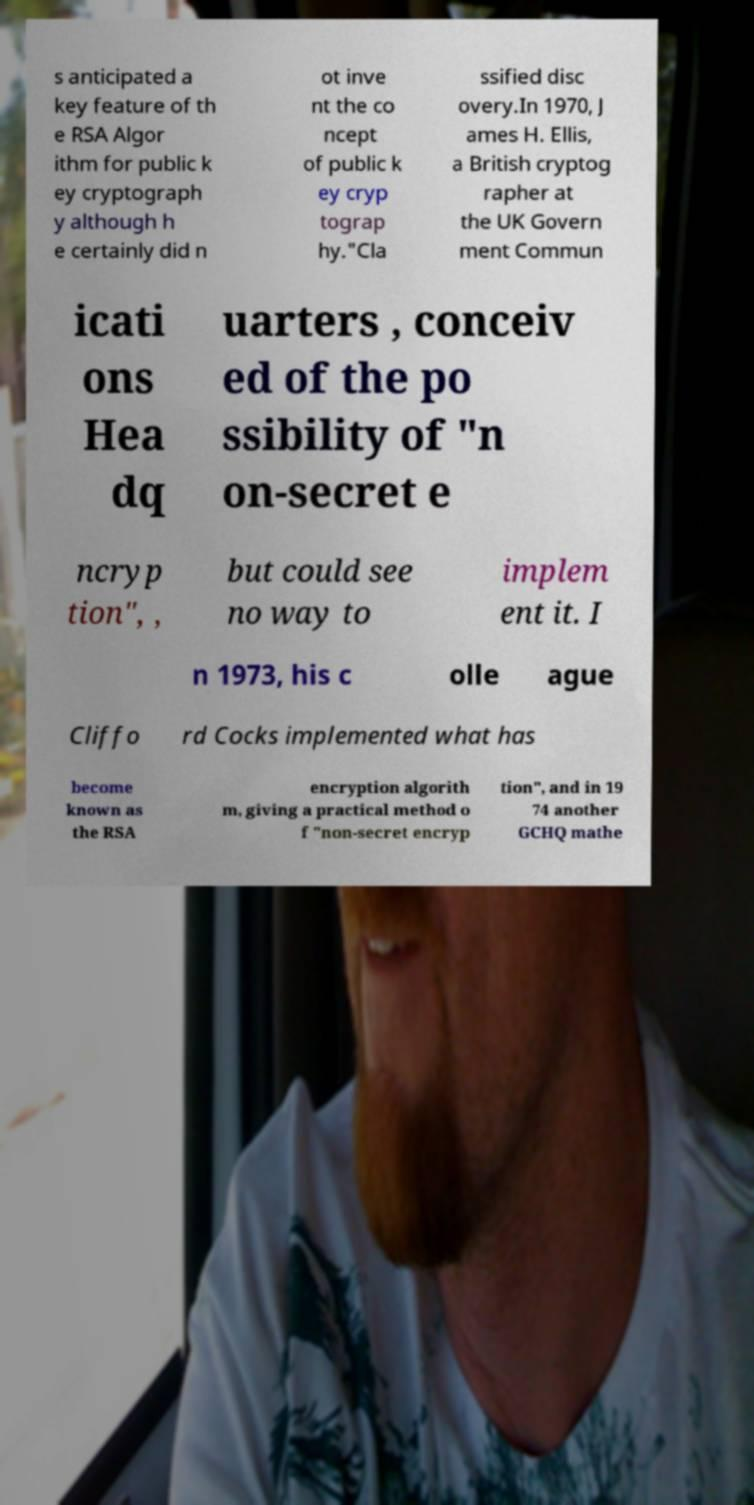Please identify and transcribe the text found in this image. s anticipated a key feature of th e RSA Algor ithm for public k ey cryptograph y although h e certainly did n ot inve nt the co ncept of public k ey cryp tograp hy."Cla ssified disc overy.In 1970, J ames H. Ellis, a British cryptog rapher at the UK Govern ment Commun icati ons Hea dq uarters , conceiv ed of the po ssibility of "n on-secret e ncryp tion", , but could see no way to implem ent it. I n 1973, his c olle ague Cliffo rd Cocks implemented what has become known as the RSA encryption algorith m, giving a practical method o f "non-secret encryp tion", and in 19 74 another GCHQ mathe 